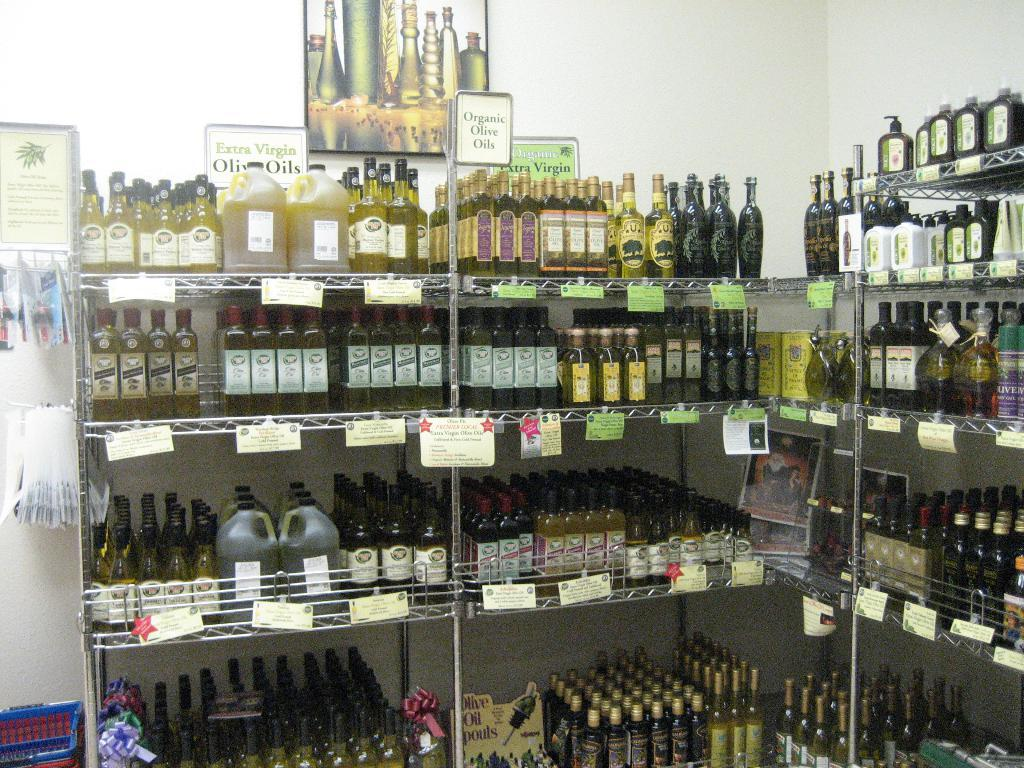What is stored on the racks in the image? The racks are filled with bottles. What additional information can be found on the racks? There are tags on the racks. What can be seen on the wall in the image? There is a picture of bottles on the wall. What type of container is present in the image? There is a basket in the image. Where is the sofa located in the image? There is no sofa present in the image. Can you tell me how many bananas are in the basket? There are no bananas in the image; only bottles and a basket are visible. 